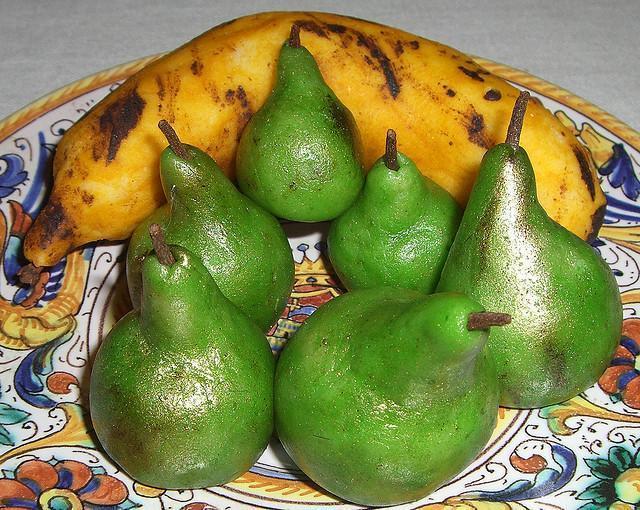How many pears are in front of the banana?
Give a very brief answer. 6. 